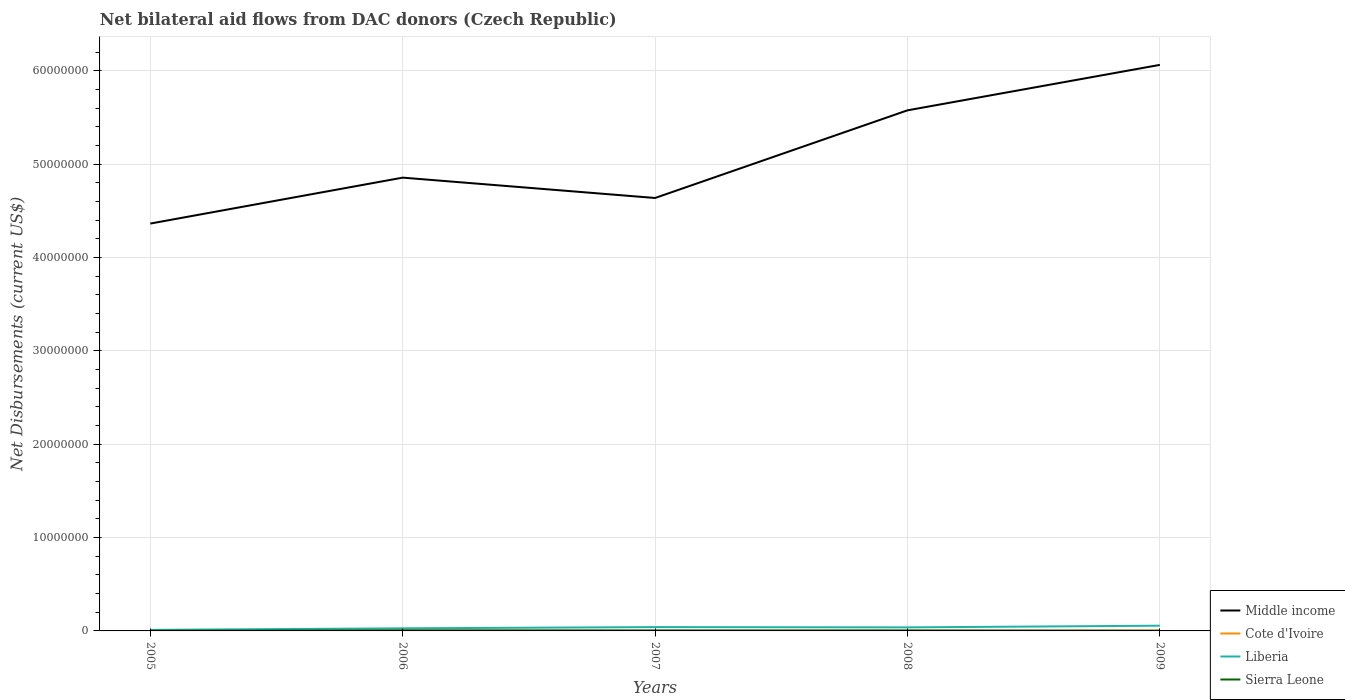Across all years, what is the maximum net bilateral aid flows in Sierra Leone?
Provide a short and direct response. 2.00e+04. What is the total net bilateral aid flows in Middle income in the graph?
Make the answer very short. -9.39e+06. What is the difference between the highest and the lowest net bilateral aid flows in Cote d'Ivoire?
Give a very brief answer. 2. What is the difference between two consecutive major ticks on the Y-axis?
Offer a terse response. 1.00e+07. Are the values on the major ticks of Y-axis written in scientific E-notation?
Keep it short and to the point. No. Does the graph contain any zero values?
Your answer should be compact. No. Does the graph contain grids?
Offer a terse response. Yes. How are the legend labels stacked?
Your answer should be very brief. Vertical. What is the title of the graph?
Make the answer very short. Net bilateral aid flows from DAC donors (Czech Republic). Does "Ireland" appear as one of the legend labels in the graph?
Provide a short and direct response. No. What is the label or title of the Y-axis?
Your answer should be compact. Net Disbursements (current US$). What is the Net Disbursements (current US$) of Middle income in 2005?
Ensure brevity in your answer.  4.36e+07. What is the Net Disbursements (current US$) of Cote d'Ivoire in 2005?
Ensure brevity in your answer.  6.00e+04. What is the Net Disbursements (current US$) of Liberia in 2005?
Keep it short and to the point. 1.10e+05. What is the Net Disbursements (current US$) of Sierra Leone in 2005?
Make the answer very short. 2.00e+04. What is the Net Disbursements (current US$) of Middle income in 2006?
Offer a terse response. 4.86e+07. What is the Net Disbursements (current US$) in Cote d'Ivoire in 2006?
Make the answer very short. 3.00e+04. What is the Net Disbursements (current US$) of Liberia in 2006?
Provide a short and direct response. 2.80e+05. What is the Net Disbursements (current US$) in Middle income in 2007?
Offer a very short reply. 4.64e+07. What is the Net Disbursements (current US$) in Cote d'Ivoire in 2007?
Make the answer very short. 10000. What is the Net Disbursements (current US$) in Liberia in 2007?
Give a very brief answer. 4.10e+05. What is the Net Disbursements (current US$) of Sierra Leone in 2007?
Offer a very short reply. 5.00e+04. What is the Net Disbursements (current US$) in Middle income in 2008?
Give a very brief answer. 5.58e+07. What is the Net Disbursements (current US$) in Liberia in 2008?
Give a very brief answer. 3.80e+05. What is the Net Disbursements (current US$) in Middle income in 2009?
Keep it short and to the point. 6.06e+07. What is the Net Disbursements (current US$) of Liberia in 2009?
Your answer should be very brief. 5.60e+05. Across all years, what is the maximum Net Disbursements (current US$) of Middle income?
Provide a succinct answer. 6.06e+07. Across all years, what is the maximum Net Disbursements (current US$) of Liberia?
Make the answer very short. 5.60e+05. Across all years, what is the maximum Net Disbursements (current US$) of Sierra Leone?
Offer a very short reply. 6.00e+04. Across all years, what is the minimum Net Disbursements (current US$) in Middle income?
Offer a terse response. 4.36e+07. What is the total Net Disbursements (current US$) of Middle income in the graph?
Offer a very short reply. 2.55e+08. What is the total Net Disbursements (current US$) in Cote d'Ivoire in the graph?
Provide a succinct answer. 1.60e+05. What is the total Net Disbursements (current US$) of Liberia in the graph?
Your response must be concise. 1.74e+06. What is the total Net Disbursements (current US$) of Sierra Leone in the graph?
Your answer should be very brief. 2.00e+05. What is the difference between the Net Disbursements (current US$) in Middle income in 2005 and that in 2006?
Give a very brief answer. -4.92e+06. What is the difference between the Net Disbursements (current US$) in Liberia in 2005 and that in 2006?
Your response must be concise. -1.70e+05. What is the difference between the Net Disbursements (current US$) of Middle income in 2005 and that in 2007?
Ensure brevity in your answer.  -2.74e+06. What is the difference between the Net Disbursements (current US$) in Cote d'Ivoire in 2005 and that in 2007?
Your answer should be compact. 5.00e+04. What is the difference between the Net Disbursements (current US$) of Middle income in 2005 and that in 2008?
Offer a very short reply. -1.21e+07. What is the difference between the Net Disbursements (current US$) in Liberia in 2005 and that in 2008?
Offer a very short reply. -2.70e+05. What is the difference between the Net Disbursements (current US$) of Sierra Leone in 2005 and that in 2008?
Your answer should be compact. -3.00e+04. What is the difference between the Net Disbursements (current US$) in Middle income in 2005 and that in 2009?
Make the answer very short. -1.70e+07. What is the difference between the Net Disbursements (current US$) in Liberia in 2005 and that in 2009?
Make the answer very short. -4.50e+05. What is the difference between the Net Disbursements (current US$) of Middle income in 2006 and that in 2007?
Your answer should be compact. 2.18e+06. What is the difference between the Net Disbursements (current US$) in Middle income in 2006 and that in 2008?
Your answer should be very brief. -7.21e+06. What is the difference between the Net Disbursements (current US$) of Cote d'Ivoire in 2006 and that in 2008?
Offer a very short reply. 10000. What is the difference between the Net Disbursements (current US$) in Liberia in 2006 and that in 2008?
Your response must be concise. -1.00e+05. What is the difference between the Net Disbursements (current US$) in Middle income in 2006 and that in 2009?
Provide a succinct answer. -1.21e+07. What is the difference between the Net Disbursements (current US$) of Liberia in 2006 and that in 2009?
Offer a terse response. -2.80e+05. What is the difference between the Net Disbursements (current US$) of Middle income in 2007 and that in 2008?
Provide a succinct answer. -9.39e+06. What is the difference between the Net Disbursements (current US$) in Cote d'Ivoire in 2007 and that in 2008?
Make the answer very short. -10000. What is the difference between the Net Disbursements (current US$) in Sierra Leone in 2007 and that in 2008?
Offer a terse response. 0. What is the difference between the Net Disbursements (current US$) in Middle income in 2007 and that in 2009?
Offer a very short reply. -1.43e+07. What is the difference between the Net Disbursements (current US$) in Middle income in 2008 and that in 2009?
Your answer should be very brief. -4.87e+06. What is the difference between the Net Disbursements (current US$) of Sierra Leone in 2008 and that in 2009?
Give a very brief answer. 3.00e+04. What is the difference between the Net Disbursements (current US$) in Middle income in 2005 and the Net Disbursements (current US$) in Cote d'Ivoire in 2006?
Your answer should be compact. 4.36e+07. What is the difference between the Net Disbursements (current US$) of Middle income in 2005 and the Net Disbursements (current US$) of Liberia in 2006?
Your response must be concise. 4.34e+07. What is the difference between the Net Disbursements (current US$) in Middle income in 2005 and the Net Disbursements (current US$) in Sierra Leone in 2006?
Give a very brief answer. 4.36e+07. What is the difference between the Net Disbursements (current US$) in Cote d'Ivoire in 2005 and the Net Disbursements (current US$) in Liberia in 2006?
Your response must be concise. -2.20e+05. What is the difference between the Net Disbursements (current US$) in Liberia in 2005 and the Net Disbursements (current US$) in Sierra Leone in 2006?
Provide a succinct answer. 5.00e+04. What is the difference between the Net Disbursements (current US$) of Middle income in 2005 and the Net Disbursements (current US$) of Cote d'Ivoire in 2007?
Offer a very short reply. 4.36e+07. What is the difference between the Net Disbursements (current US$) in Middle income in 2005 and the Net Disbursements (current US$) in Liberia in 2007?
Your answer should be compact. 4.32e+07. What is the difference between the Net Disbursements (current US$) in Middle income in 2005 and the Net Disbursements (current US$) in Sierra Leone in 2007?
Ensure brevity in your answer.  4.36e+07. What is the difference between the Net Disbursements (current US$) in Cote d'Ivoire in 2005 and the Net Disbursements (current US$) in Liberia in 2007?
Offer a terse response. -3.50e+05. What is the difference between the Net Disbursements (current US$) in Cote d'Ivoire in 2005 and the Net Disbursements (current US$) in Sierra Leone in 2007?
Your answer should be compact. 10000. What is the difference between the Net Disbursements (current US$) of Liberia in 2005 and the Net Disbursements (current US$) of Sierra Leone in 2007?
Offer a very short reply. 6.00e+04. What is the difference between the Net Disbursements (current US$) of Middle income in 2005 and the Net Disbursements (current US$) of Cote d'Ivoire in 2008?
Offer a terse response. 4.36e+07. What is the difference between the Net Disbursements (current US$) of Middle income in 2005 and the Net Disbursements (current US$) of Liberia in 2008?
Offer a very short reply. 4.33e+07. What is the difference between the Net Disbursements (current US$) in Middle income in 2005 and the Net Disbursements (current US$) in Sierra Leone in 2008?
Give a very brief answer. 4.36e+07. What is the difference between the Net Disbursements (current US$) in Cote d'Ivoire in 2005 and the Net Disbursements (current US$) in Liberia in 2008?
Your answer should be compact. -3.20e+05. What is the difference between the Net Disbursements (current US$) of Cote d'Ivoire in 2005 and the Net Disbursements (current US$) of Sierra Leone in 2008?
Give a very brief answer. 10000. What is the difference between the Net Disbursements (current US$) of Liberia in 2005 and the Net Disbursements (current US$) of Sierra Leone in 2008?
Your response must be concise. 6.00e+04. What is the difference between the Net Disbursements (current US$) in Middle income in 2005 and the Net Disbursements (current US$) in Cote d'Ivoire in 2009?
Offer a terse response. 4.36e+07. What is the difference between the Net Disbursements (current US$) in Middle income in 2005 and the Net Disbursements (current US$) in Liberia in 2009?
Offer a very short reply. 4.31e+07. What is the difference between the Net Disbursements (current US$) in Middle income in 2005 and the Net Disbursements (current US$) in Sierra Leone in 2009?
Your response must be concise. 4.36e+07. What is the difference between the Net Disbursements (current US$) of Cote d'Ivoire in 2005 and the Net Disbursements (current US$) of Liberia in 2009?
Make the answer very short. -5.00e+05. What is the difference between the Net Disbursements (current US$) in Liberia in 2005 and the Net Disbursements (current US$) in Sierra Leone in 2009?
Keep it short and to the point. 9.00e+04. What is the difference between the Net Disbursements (current US$) in Middle income in 2006 and the Net Disbursements (current US$) in Cote d'Ivoire in 2007?
Make the answer very short. 4.86e+07. What is the difference between the Net Disbursements (current US$) in Middle income in 2006 and the Net Disbursements (current US$) in Liberia in 2007?
Provide a succinct answer. 4.82e+07. What is the difference between the Net Disbursements (current US$) in Middle income in 2006 and the Net Disbursements (current US$) in Sierra Leone in 2007?
Ensure brevity in your answer.  4.85e+07. What is the difference between the Net Disbursements (current US$) of Cote d'Ivoire in 2006 and the Net Disbursements (current US$) of Liberia in 2007?
Keep it short and to the point. -3.80e+05. What is the difference between the Net Disbursements (current US$) of Cote d'Ivoire in 2006 and the Net Disbursements (current US$) of Sierra Leone in 2007?
Provide a short and direct response. -2.00e+04. What is the difference between the Net Disbursements (current US$) in Liberia in 2006 and the Net Disbursements (current US$) in Sierra Leone in 2007?
Your response must be concise. 2.30e+05. What is the difference between the Net Disbursements (current US$) of Middle income in 2006 and the Net Disbursements (current US$) of Cote d'Ivoire in 2008?
Offer a terse response. 4.85e+07. What is the difference between the Net Disbursements (current US$) of Middle income in 2006 and the Net Disbursements (current US$) of Liberia in 2008?
Ensure brevity in your answer.  4.82e+07. What is the difference between the Net Disbursements (current US$) in Middle income in 2006 and the Net Disbursements (current US$) in Sierra Leone in 2008?
Provide a short and direct response. 4.85e+07. What is the difference between the Net Disbursements (current US$) in Cote d'Ivoire in 2006 and the Net Disbursements (current US$) in Liberia in 2008?
Your answer should be very brief. -3.50e+05. What is the difference between the Net Disbursements (current US$) in Cote d'Ivoire in 2006 and the Net Disbursements (current US$) in Sierra Leone in 2008?
Offer a very short reply. -2.00e+04. What is the difference between the Net Disbursements (current US$) in Liberia in 2006 and the Net Disbursements (current US$) in Sierra Leone in 2008?
Offer a very short reply. 2.30e+05. What is the difference between the Net Disbursements (current US$) of Middle income in 2006 and the Net Disbursements (current US$) of Cote d'Ivoire in 2009?
Make the answer very short. 4.85e+07. What is the difference between the Net Disbursements (current US$) in Middle income in 2006 and the Net Disbursements (current US$) in Liberia in 2009?
Provide a succinct answer. 4.80e+07. What is the difference between the Net Disbursements (current US$) in Middle income in 2006 and the Net Disbursements (current US$) in Sierra Leone in 2009?
Offer a very short reply. 4.85e+07. What is the difference between the Net Disbursements (current US$) of Cote d'Ivoire in 2006 and the Net Disbursements (current US$) of Liberia in 2009?
Your answer should be very brief. -5.30e+05. What is the difference between the Net Disbursements (current US$) in Cote d'Ivoire in 2006 and the Net Disbursements (current US$) in Sierra Leone in 2009?
Your response must be concise. 10000. What is the difference between the Net Disbursements (current US$) in Middle income in 2007 and the Net Disbursements (current US$) in Cote d'Ivoire in 2008?
Make the answer very short. 4.64e+07. What is the difference between the Net Disbursements (current US$) in Middle income in 2007 and the Net Disbursements (current US$) in Liberia in 2008?
Your response must be concise. 4.60e+07. What is the difference between the Net Disbursements (current US$) of Middle income in 2007 and the Net Disbursements (current US$) of Sierra Leone in 2008?
Offer a very short reply. 4.63e+07. What is the difference between the Net Disbursements (current US$) in Cote d'Ivoire in 2007 and the Net Disbursements (current US$) in Liberia in 2008?
Your answer should be compact. -3.70e+05. What is the difference between the Net Disbursements (current US$) in Liberia in 2007 and the Net Disbursements (current US$) in Sierra Leone in 2008?
Make the answer very short. 3.60e+05. What is the difference between the Net Disbursements (current US$) of Middle income in 2007 and the Net Disbursements (current US$) of Cote d'Ivoire in 2009?
Offer a very short reply. 4.63e+07. What is the difference between the Net Disbursements (current US$) of Middle income in 2007 and the Net Disbursements (current US$) of Liberia in 2009?
Provide a short and direct response. 4.58e+07. What is the difference between the Net Disbursements (current US$) in Middle income in 2007 and the Net Disbursements (current US$) in Sierra Leone in 2009?
Make the answer very short. 4.64e+07. What is the difference between the Net Disbursements (current US$) in Cote d'Ivoire in 2007 and the Net Disbursements (current US$) in Liberia in 2009?
Your answer should be very brief. -5.50e+05. What is the difference between the Net Disbursements (current US$) of Middle income in 2008 and the Net Disbursements (current US$) of Cote d'Ivoire in 2009?
Your answer should be compact. 5.57e+07. What is the difference between the Net Disbursements (current US$) of Middle income in 2008 and the Net Disbursements (current US$) of Liberia in 2009?
Keep it short and to the point. 5.52e+07. What is the difference between the Net Disbursements (current US$) in Middle income in 2008 and the Net Disbursements (current US$) in Sierra Leone in 2009?
Offer a very short reply. 5.58e+07. What is the difference between the Net Disbursements (current US$) of Cote d'Ivoire in 2008 and the Net Disbursements (current US$) of Liberia in 2009?
Your answer should be very brief. -5.40e+05. What is the average Net Disbursements (current US$) of Middle income per year?
Your response must be concise. 5.10e+07. What is the average Net Disbursements (current US$) in Cote d'Ivoire per year?
Offer a very short reply. 3.20e+04. What is the average Net Disbursements (current US$) of Liberia per year?
Provide a succinct answer. 3.48e+05. In the year 2005, what is the difference between the Net Disbursements (current US$) of Middle income and Net Disbursements (current US$) of Cote d'Ivoire?
Give a very brief answer. 4.36e+07. In the year 2005, what is the difference between the Net Disbursements (current US$) in Middle income and Net Disbursements (current US$) in Liberia?
Your answer should be compact. 4.35e+07. In the year 2005, what is the difference between the Net Disbursements (current US$) in Middle income and Net Disbursements (current US$) in Sierra Leone?
Offer a terse response. 4.36e+07. In the year 2005, what is the difference between the Net Disbursements (current US$) of Cote d'Ivoire and Net Disbursements (current US$) of Liberia?
Provide a short and direct response. -5.00e+04. In the year 2005, what is the difference between the Net Disbursements (current US$) of Cote d'Ivoire and Net Disbursements (current US$) of Sierra Leone?
Your answer should be very brief. 4.00e+04. In the year 2005, what is the difference between the Net Disbursements (current US$) of Liberia and Net Disbursements (current US$) of Sierra Leone?
Keep it short and to the point. 9.00e+04. In the year 2006, what is the difference between the Net Disbursements (current US$) of Middle income and Net Disbursements (current US$) of Cote d'Ivoire?
Provide a succinct answer. 4.85e+07. In the year 2006, what is the difference between the Net Disbursements (current US$) in Middle income and Net Disbursements (current US$) in Liberia?
Offer a very short reply. 4.83e+07. In the year 2006, what is the difference between the Net Disbursements (current US$) in Middle income and Net Disbursements (current US$) in Sierra Leone?
Keep it short and to the point. 4.85e+07. In the year 2006, what is the difference between the Net Disbursements (current US$) of Cote d'Ivoire and Net Disbursements (current US$) of Liberia?
Offer a terse response. -2.50e+05. In the year 2006, what is the difference between the Net Disbursements (current US$) in Cote d'Ivoire and Net Disbursements (current US$) in Sierra Leone?
Your response must be concise. -3.00e+04. In the year 2006, what is the difference between the Net Disbursements (current US$) of Liberia and Net Disbursements (current US$) of Sierra Leone?
Your answer should be very brief. 2.20e+05. In the year 2007, what is the difference between the Net Disbursements (current US$) of Middle income and Net Disbursements (current US$) of Cote d'Ivoire?
Ensure brevity in your answer.  4.64e+07. In the year 2007, what is the difference between the Net Disbursements (current US$) of Middle income and Net Disbursements (current US$) of Liberia?
Offer a very short reply. 4.60e+07. In the year 2007, what is the difference between the Net Disbursements (current US$) in Middle income and Net Disbursements (current US$) in Sierra Leone?
Keep it short and to the point. 4.63e+07. In the year 2007, what is the difference between the Net Disbursements (current US$) in Cote d'Ivoire and Net Disbursements (current US$) in Liberia?
Give a very brief answer. -4.00e+05. In the year 2007, what is the difference between the Net Disbursements (current US$) of Cote d'Ivoire and Net Disbursements (current US$) of Sierra Leone?
Give a very brief answer. -4.00e+04. In the year 2007, what is the difference between the Net Disbursements (current US$) in Liberia and Net Disbursements (current US$) in Sierra Leone?
Provide a short and direct response. 3.60e+05. In the year 2008, what is the difference between the Net Disbursements (current US$) in Middle income and Net Disbursements (current US$) in Cote d'Ivoire?
Provide a succinct answer. 5.58e+07. In the year 2008, what is the difference between the Net Disbursements (current US$) in Middle income and Net Disbursements (current US$) in Liberia?
Your response must be concise. 5.54e+07. In the year 2008, what is the difference between the Net Disbursements (current US$) of Middle income and Net Disbursements (current US$) of Sierra Leone?
Give a very brief answer. 5.57e+07. In the year 2008, what is the difference between the Net Disbursements (current US$) in Cote d'Ivoire and Net Disbursements (current US$) in Liberia?
Your answer should be compact. -3.60e+05. In the year 2008, what is the difference between the Net Disbursements (current US$) of Cote d'Ivoire and Net Disbursements (current US$) of Sierra Leone?
Provide a succinct answer. -3.00e+04. In the year 2009, what is the difference between the Net Disbursements (current US$) of Middle income and Net Disbursements (current US$) of Cote d'Ivoire?
Provide a short and direct response. 6.06e+07. In the year 2009, what is the difference between the Net Disbursements (current US$) of Middle income and Net Disbursements (current US$) of Liberia?
Offer a very short reply. 6.01e+07. In the year 2009, what is the difference between the Net Disbursements (current US$) in Middle income and Net Disbursements (current US$) in Sierra Leone?
Keep it short and to the point. 6.06e+07. In the year 2009, what is the difference between the Net Disbursements (current US$) of Cote d'Ivoire and Net Disbursements (current US$) of Liberia?
Ensure brevity in your answer.  -5.20e+05. In the year 2009, what is the difference between the Net Disbursements (current US$) in Liberia and Net Disbursements (current US$) in Sierra Leone?
Offer a very short reply. 5.40e+05. What is the ratio of the Net Disbursements (current US$) in Middle income in 2005 to that in 2006?
Make the answer very short. 0.9. What is the ratio of the Net Disbursements (current US$) in Cote d'Ivoire in 2005 to that in 2006?
Offer a very short reply. 2. What is the ratio of the Net Disbursements (current US$) in Liberia in 2005 to that in 2006?
Give a very brief answer. 0.39. What is the ratio of the Net Disbursements (current US$) in Middle income in 2005 to that in 2007?
Provide a short and direct response. 0.94. What is the ratio of the Net Disbursements (current US$) of Liberia in 2005 to that in 2007?
Make the answer very short. 0.27. What is the ratio of the Net Disbursements (current US$) in Sierra Leone in 2005 to that in 2007?
Offer a very short reply. 0.4. What is the ratio of the Net Disbursements (current US$) of Middle income in 2005 to that in 2008?
Ensure brevity in your answer.  0.78. What is the ratio of the Net Disbursements (current US$) in Liberia in 2005 to that in 2008?
Keep it short and to the point. 0.29. What is the ratio of the Net Disbursements (current US$) in Middle income in 2005 to that in 2009?
Give a very brief answer. 0.72. What is the ratio of the Net Disbursements (current US$) of Liberia in 2005 to that in 2009?
Offer a very short reply. 0.2. What is the ratio of the Net Disbursements (current US$) in Middle income in 2006 to that in 2007?
Offer a very short reply. 1.05. What is the ratio of the Net Disbursements (current US$) in Liberia in 2006 to that in 2007?
Offer a very short reply. 0.68. What is the ratio of the Net Disbursements (current US$) in Middle income in 2006 to that in 2008?
Your answer should be compact. 0.87. What is the ratio of the Net Disbursements (current US$) of Cote d'Ivoire in 2006 to that in 2008?
Make the answer very short. 1.5. What is the ratio of the Net Disbursements (current US$) of Liberia in 2006 to that in 2008?
Your answer should be very brief. 0.74. What is the ratio of the Net Disbursements (current US$) in Sierra Leone in 2006 to that in 2008?
Your answer should be very brief. 1.2. What is the ratio of the Net Disbursements (current US$) in Middle income in 2006 to that in 2009?
Make the answer very short. 0.8. What is the ratio of the Net Disbursements (current US$) of Cote d'Ivoire in 2006 to that in 2009?
Offer a terse response. 0.75. What is the ratio of the Net Disbursements (current US$) in Liberia in 2006 to that in 2009?
Your answer should be very brief. 0.5. What is the ratio of the Net Disbursements (current US$) of Sierra Leone in 2006 to that in 2009?
Give a very brief answer. 3. What is the ratio of the Net Disbursements (current US$) of Middle income in 2007 to that in 2008?
Your response must be concise. 0.83. What is the ratio of the Net Disbursements (current US$) of Cote d'Ivoire in 2007 to that in 2008?
Your response must be concise. 0.5. What is the ratio of the Net Disbursements (current US$) in Liberia in 2007 to that in 2008?
Your answer should be very brief. 1.08. What is the ratio of the Net Disbursements (current US$) in Middle income in 2007 to that in 2009?
Make the answer very short. 0.76. What is the ratio of the Net Disbursements (current US$) in Liberia in 2007 to that in 2009?
Ensure brevity in your answer.  0.73. What is the ratio of the Net Disbursements (current US$) of Middle income in 2008 to that in 2009?
Provide a short and direct response. 0.92. What is the ratio of the Net Disbursements (current US$) of Cote d'Ivoire in 2008 to that in 2009?
Offer a very short reply. 0.5. What is the ratio of the Net Disbursements (current US$) of Liberia in 2008 to that in 2009?
Your answer should be very brief. 0.68. What is the difference between the highest and the second highest Net Disbursements (current US$) of Middle income?
Offer a very short reply. 4.87e+06. What is the difference between the highest and the second highest Net Disbursements (current US$) in Cote d'Ivoire?
Ensure brevity in your answer.  2.00e+04. What is the difference between the highest and the second highest Net Disbursements (current US$) in Liberia?
Keep it short and to the point. 1.50e+05. What is the difference between the highest and the lowest Net Disbursements (current US$) in Middle income?
Make the answer very short. 1.70e+07. What is the difference between the highest and the lowest Net Disbursements (current US$) in Cote d'Ivoire?
Keep it short and to the point. 5.00e+04. What is the difference between the highest and the lowest Net Disbursements (current US$) in Liberia?
Your answer should be very brief. 4.50e+05. What is the difference between the highest and the lowest Net Disbursements (current US$) in Sierra Leone?
Offer a very short reply. 4.00e+04. 